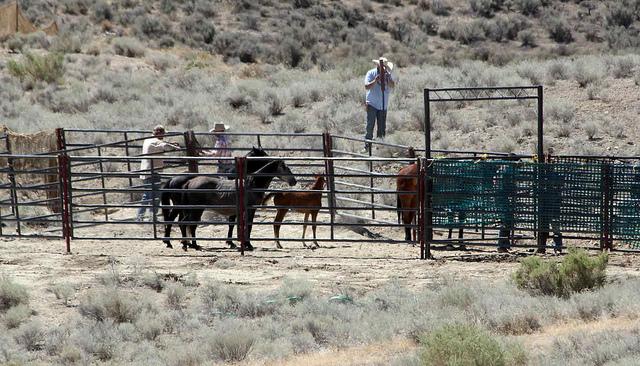How many horses are there?
Answer briefly. 4. What color is the grass?
Keep it brief. Brown. Is someone holding a camera?
Answer briefly. Yes. 